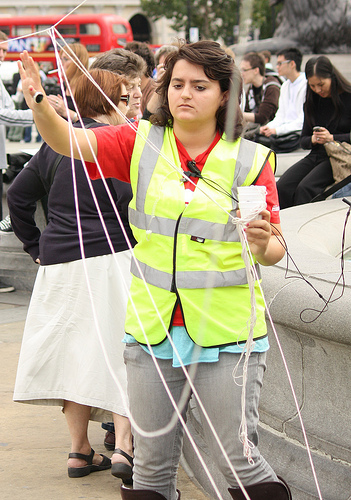<image>
Can you confirm if the tree is behind the lady? Yes. From this viewpoint, the tree is positioned behind the lady, with the lady partially or fully occluding the tree. 